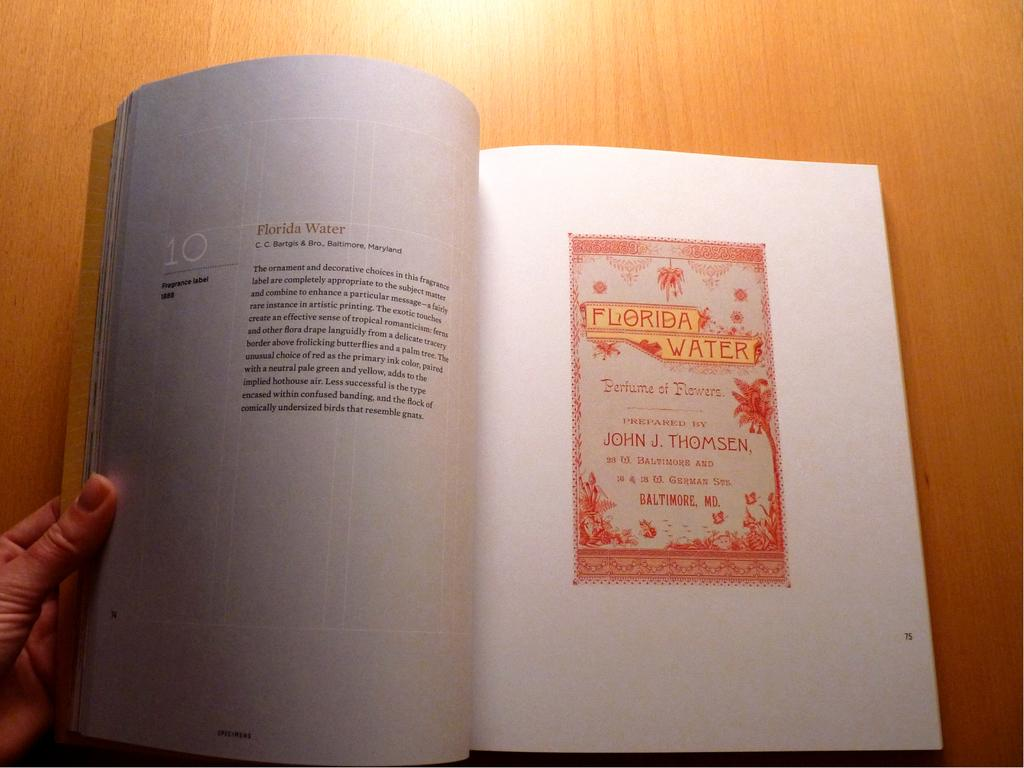<image>
Create a compact narrative representing the image presented. The perfume of flowers was prepared by John J Thomsen. 